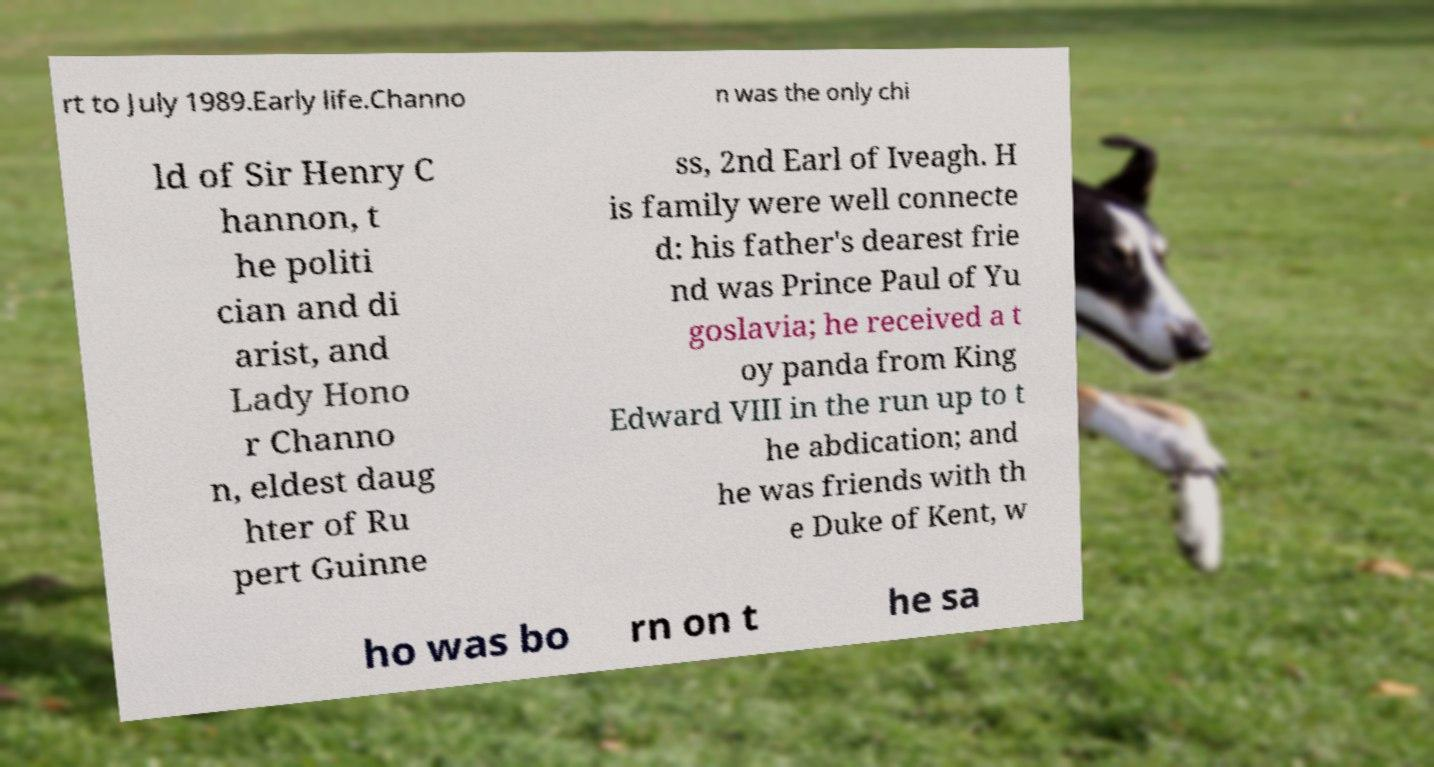Please read and relay the text visible in this image. What does it say? rt to July 1989.Early life.Channo n was the only chi ld of Sir Henry C hannon, t he politi cian and di arist, and Lady Hono r Channo n, eldest daug hter of Ru pert Guinne ss, 2nd Earl of Iveagh. H is family were well connecte d: his father's dearest frie nd was Prince Paul of Yu goslavia; he received a t oy panda from King Edward VIII in the run up to t he abdication; and he was friends with th e Duke of Kent, w ho was bo rn on t he sa 